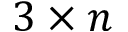<formula> <loc_0><loc_0><loc_500><loc_500>3 \times n</formula> 